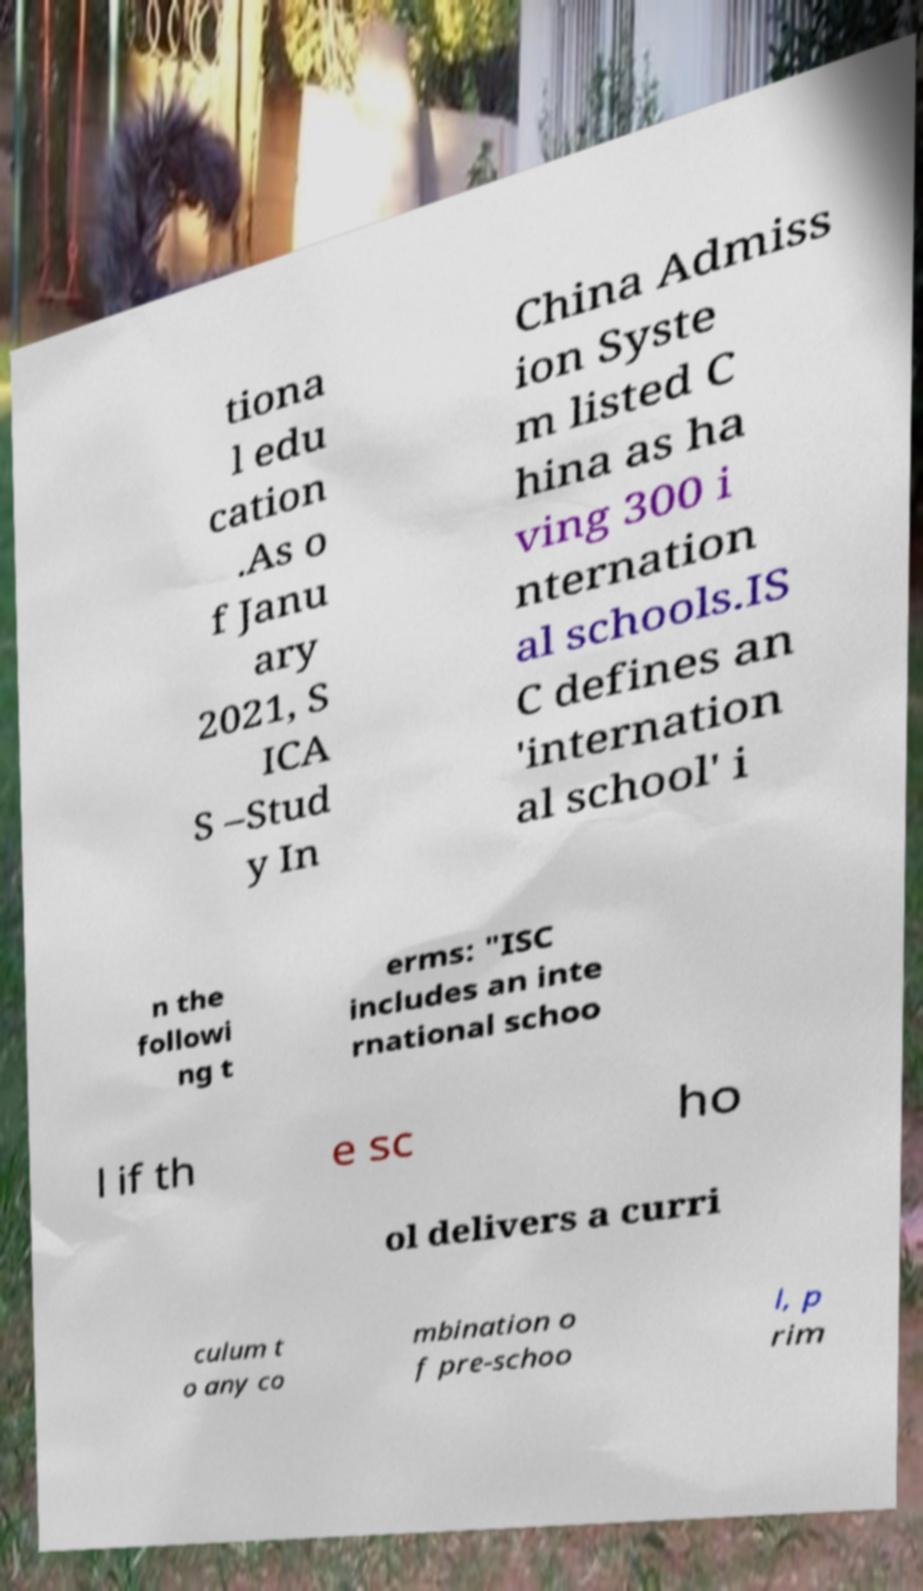What messages or text are displayed in this image? I need them in a readable, typed format. tiona l edu cation .As o f Janu ary 2021, S ICA S –Stud y In China Admiss ion Syste m listed C hina as ha ving 300 i nternation al schools.IS C defines an 'internation al school' i n the followi ng t erms: "ISC includes an inte rnational schoo l if th e sc ho ol delivers a curri culum t o any co mbination o f pre-schoo l, p rim 